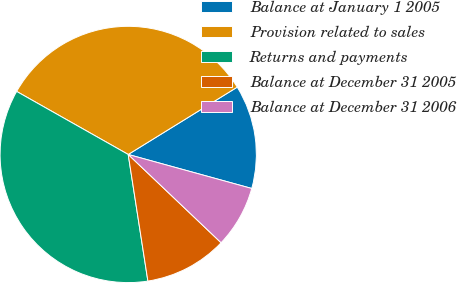Convert chart to OTSL. <chart><loc_0><loc_0><loc_500><loc_500><pie_chart><fcel>Balance at January 1 2005<fcel>Provision related to sales<fcel>Returns and payments<fcel>Balance at December 31 2005<fcel>Balance at December 31 2006<nl><fcel>13.08%<fcel>33.01%<fcel>35.64%<fcel>10.45%<fcel>7.82%<nl></chart> 